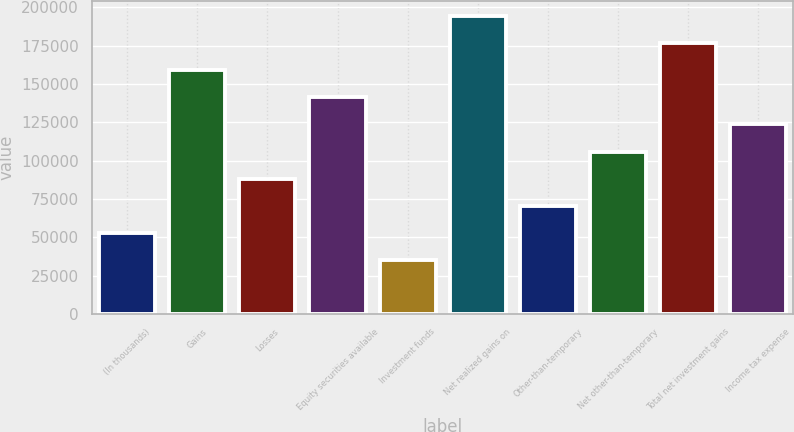Convert chart to OTSL. <chart><loc_0><loc_0><loc_500><loc_500><bar_chart><fcel>(In thousands)<fcel>Gains<fcel>Losses<fcel>Equity securities available<fcel>Investment funds<fcel>Net realized gains on<fcel>Other-than-temporary<fcel>Net other-than-temporary<fcel>Total net investment gains<fcel>Income tax expense<nl><fcel>52982<fcel>158930<fcel>88298<fcel>141272<fcel>35324<fcel>194246<fcel>70640<fcel>105956<fcel>176588<fcel>123614<nl></chart> 